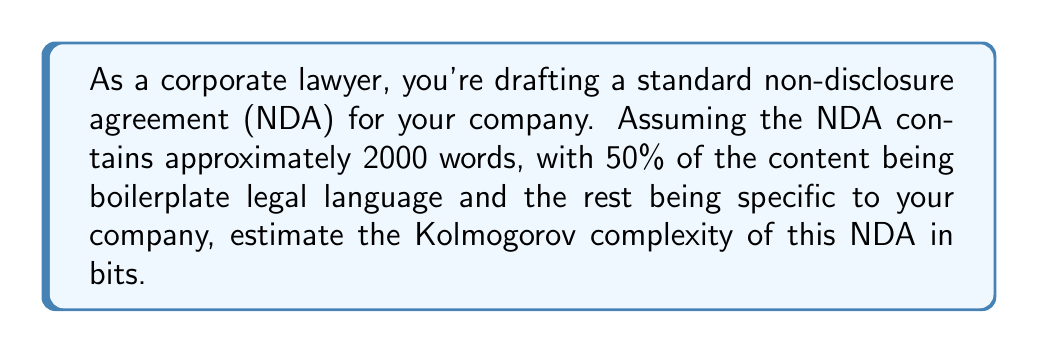What is the answer to this math problem? To estimate the Kolmogorov complexity of the NDA, we need to consider the shortest possible program that could generate this document. Let's break it down step-by-step:

1. Boilerplate content:
   - 50% of 2000 words ≈ 1000 words
   - Assuming an average of 5 characters per word, we have 5000 characters
   - Standard legal boilerplate can be compressed efficiently, let's estimate 2 bits per character
   - Boilerplate complexity: $1000 \times 5 \times 2 = 10000$ bits

2. Company-specific content:
   - Also 1000 words or 5000 characters
   - This content is more unique and less compressible, let's estimate 4 bits per character
   - Company-specific complexity: $1000 \times 5 \times 4 = 20000$ bits

3. Structure and formatting:
   - We need some additional bits to describe the document structure, formatting, and how to combine the boilerplate with specific content
   - Let's estimate this at about 1000 bits

4. Program overhead:
   - The program to generate the document needs some overhead for logic and control structures
   - Let's estimate this at about 500 bits

Total estimated Kolmogorov complexity:
$$K(NDA) \approx 10000 + 20000 + 1000 + 500 = 31500 \text{ bits}$$

This estimate assumes that the boilerplate content can be generated from a relatively small set of legal phrases and structures, while the company-specific content requires more detailed description. The actual complexity could vary based on the specific content and structure of the NDA, but this provides a reasonable order-of-magnitude estimate.
Answer: The estimated Kolmogorov complexity of the NDA is approximately 31500 bits. 